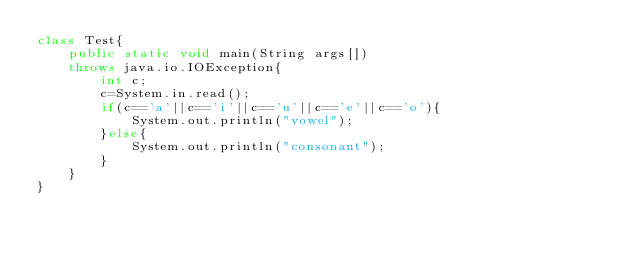<code> <loc_0><loc_0><loc_500><loc_500><_Java_>class Test{
	public static void main(String args[])
	throws java.io.IOException{
		int c;
		c=System.in.read();
		if(c=='a'||c=='i'||c=='u'||c=='e'||c=='o'){
			System.out.println("vowel");
		}else{
			System.out.println("consonant");
		}	
	}
}
</code> 